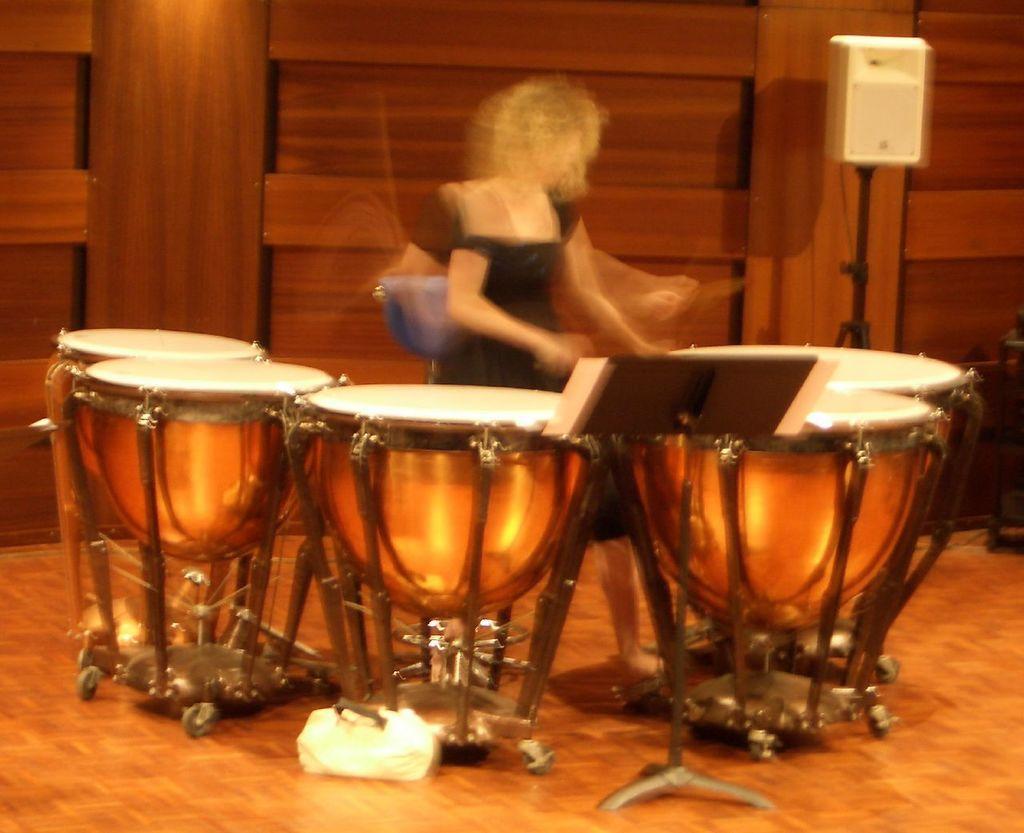Could you give a brief overview of what you see in this image? In this image, we can see a person. We can see the ground with some objects. We can see some musical instruments and a pole with a white colored object. We can see the wooden wall. We can also see some objects on the right. 